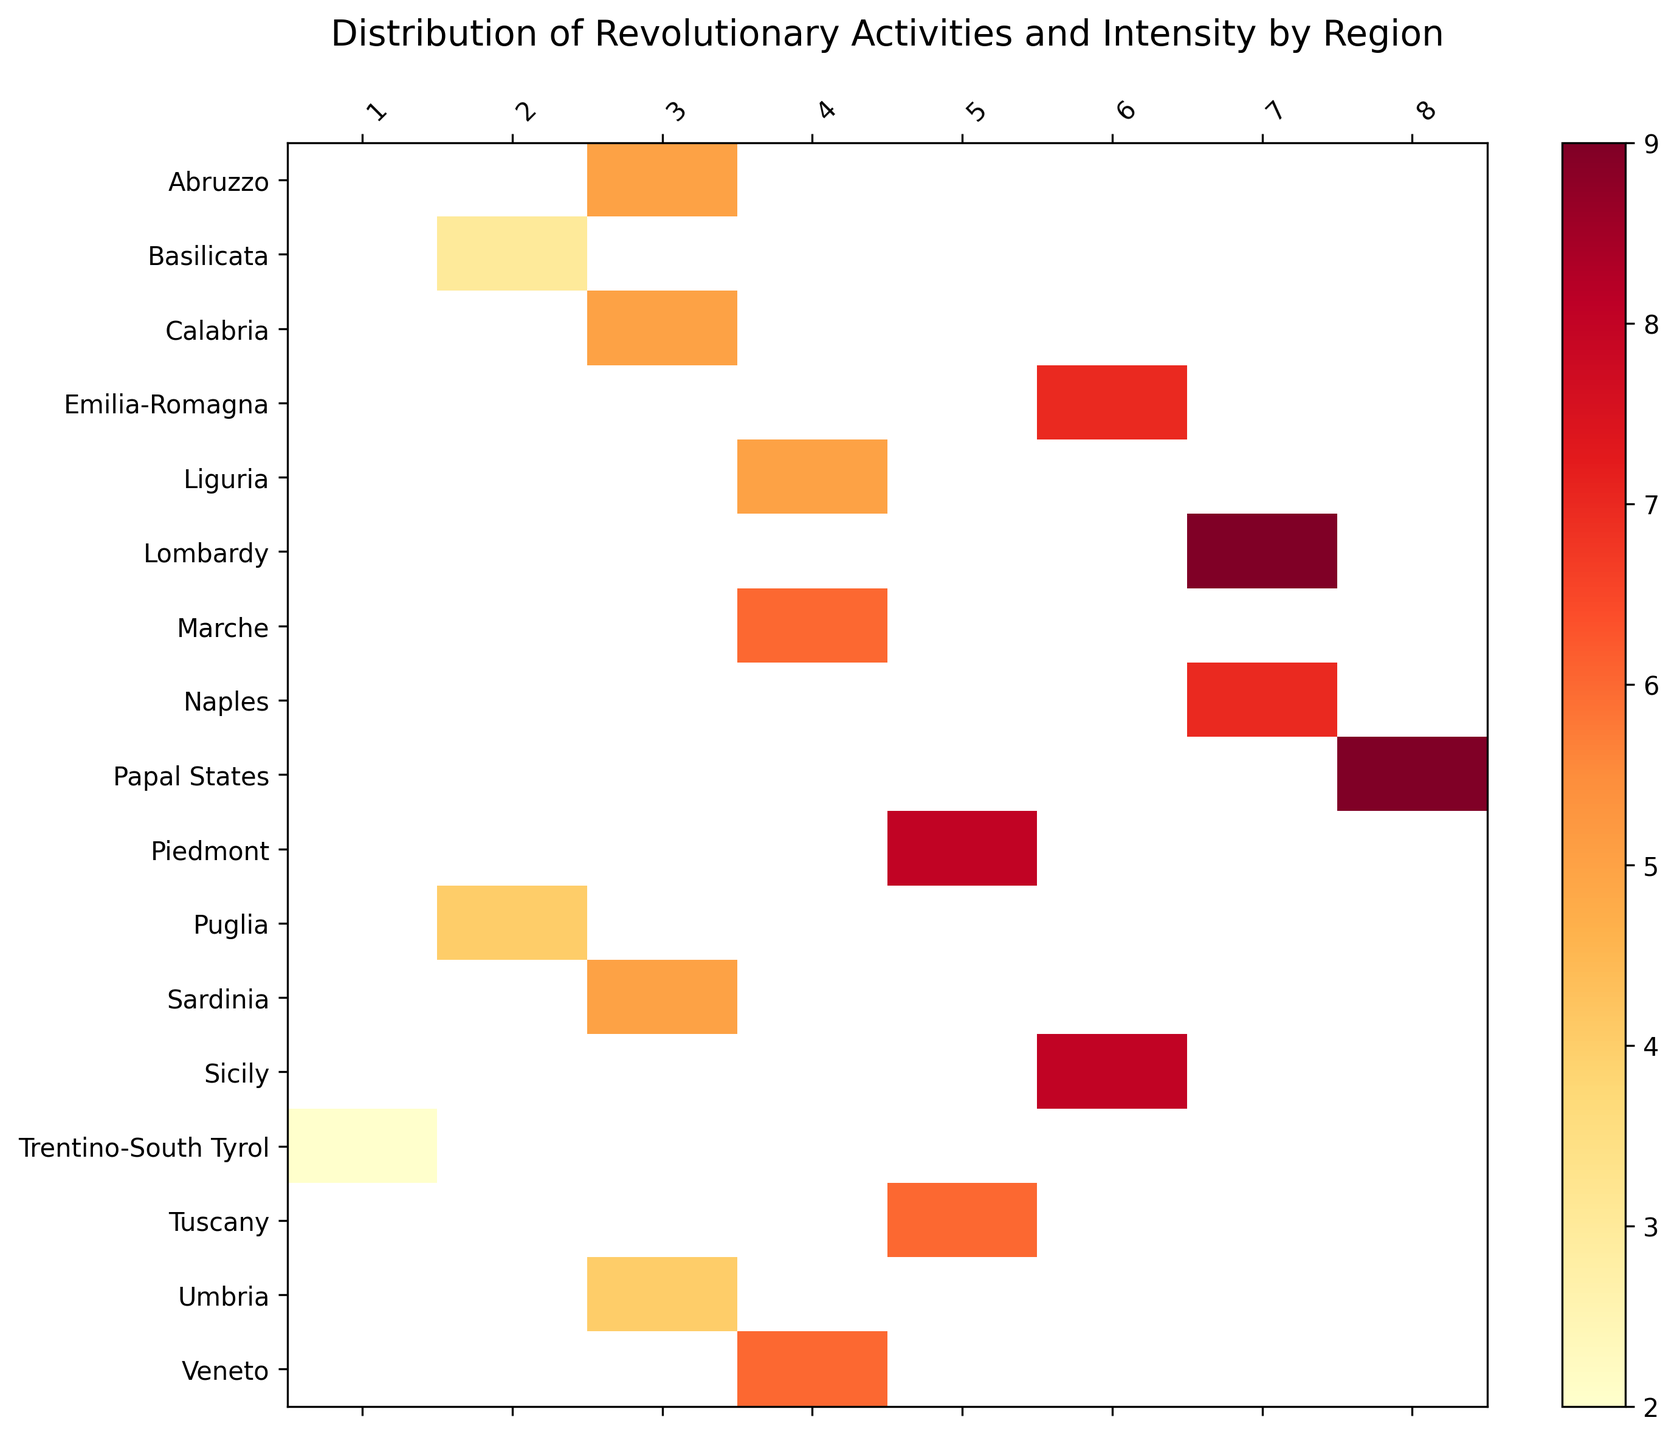How many regions have an intensity value greater than or equal to 6? To determine this, look for regions where the color represents an intensity of 6 or higher. Count these regions.
Answer: 10 Which region has the highest intensity value? Identify the darkest color on the heatmap which should have the highest intensity value. Match this color to its corresponding region.
Answer: Papal States Which region has the lowest number of revolutionary activities? Find the region with the lowest (lightest) shade of revolutionary activities column. Corresponding region reflects in the index label.
Answer: Trentino-South Tyrol Is the intensity in Tuscany higher or lower compared to Emilia-Romagna? Locate both regions on the heatmap, then compare the color intensity values of the two.
Answer: Lower What is the difference in intensity between Veneto and Calabria? Determine the intensity value for both Veneto and Calabria from the heatmap and then subtract the intensity of Calabria from Veneto.
Answer: 1 Do regions with more revolutionary activities always correlate with higher intensities? Review if the shade representing higher revolutionary activities consistently shows a higher intensity visually across the heatmap.
Answer: No How many regions have 4 revolutionary activities? Find regions corresponding to Revolutionary_Activities with a value of 4. Count these regions.
Answer: 3 Among Sicily, Naples, and Sardinia, which region has the lowest intensity? Identify the color and its related intensity value for each of Sicily, Naples, and Sardinia. Compare them to find the lowest.
Answer: Sardinia Do Northern regions generally have higher intensities compared to Southern regions like Calabria and Basilicata? Compare the intensity shades of Northern regions (e.g., Piedmont, Lombardy) with Southern regions (e.g., Calabria, Basilicata).
Answer: Yes What is the sum of the revolutionary activities in the regions with the highest intensity? Identify the regions with the highest intensity, then sum their revolutionary activities. Highest intensity is 9, corresponding regions are Lombardy, Papal States.
Answer: 15 